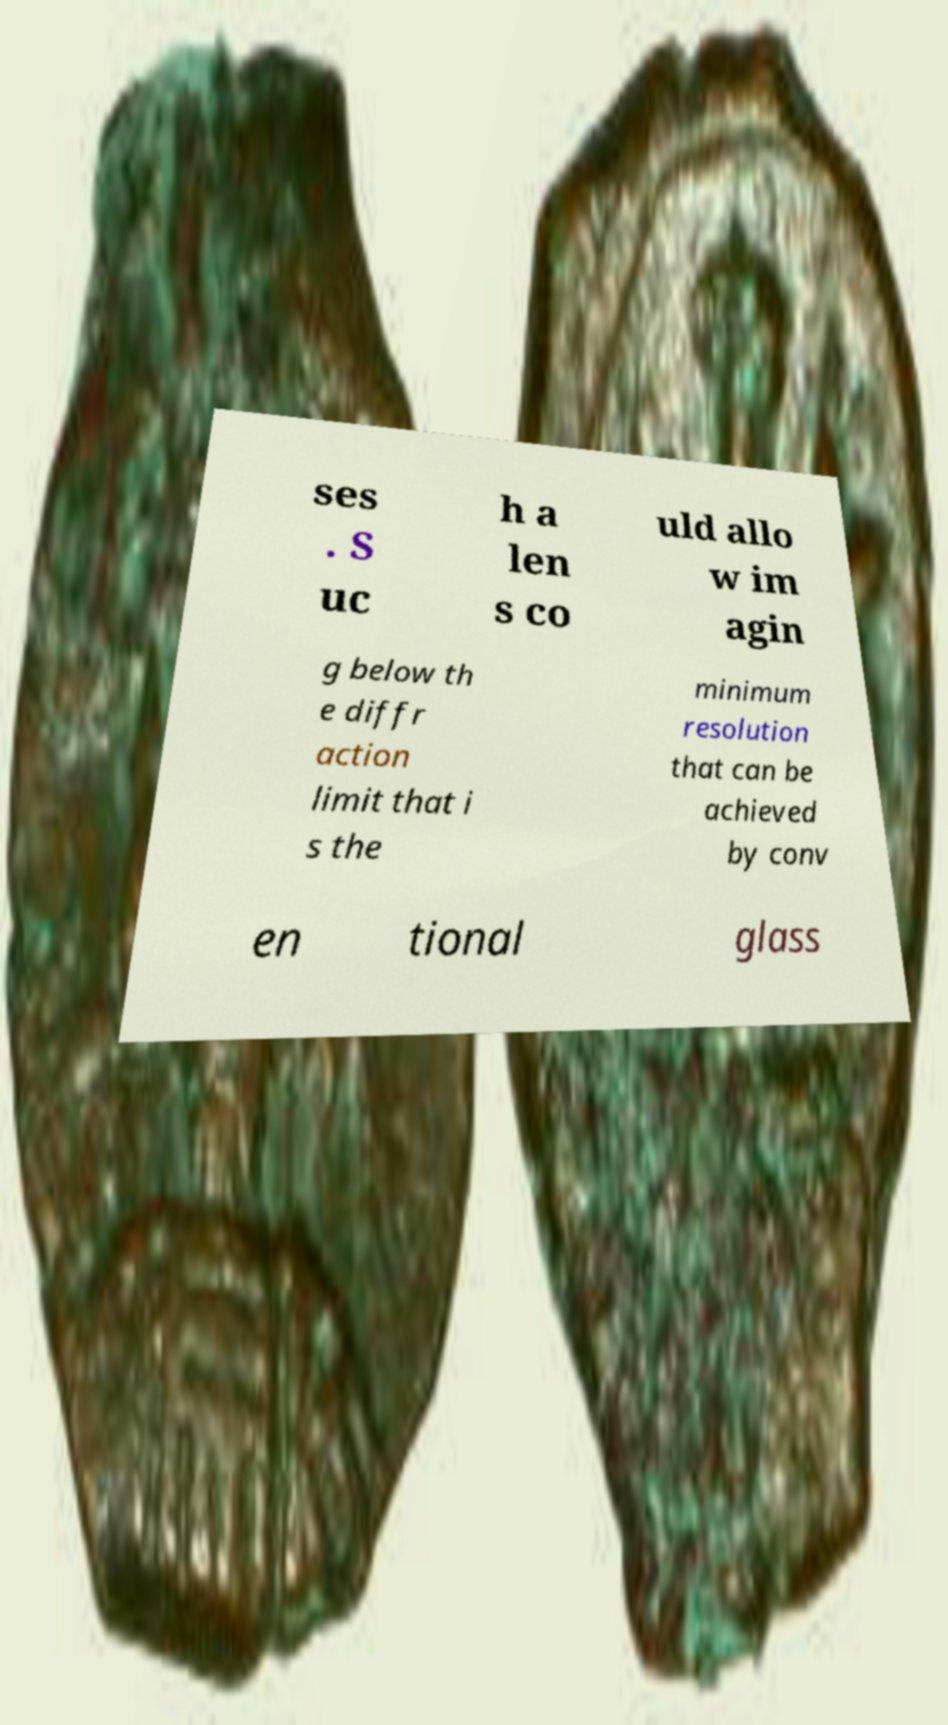Can you accurately transcribe the text from the provided image for me? ses . S uc h a len s co uld allo w im agin g below th e diffr action limit that i s the minimum resolution that can be achieved by conv en tional glass 